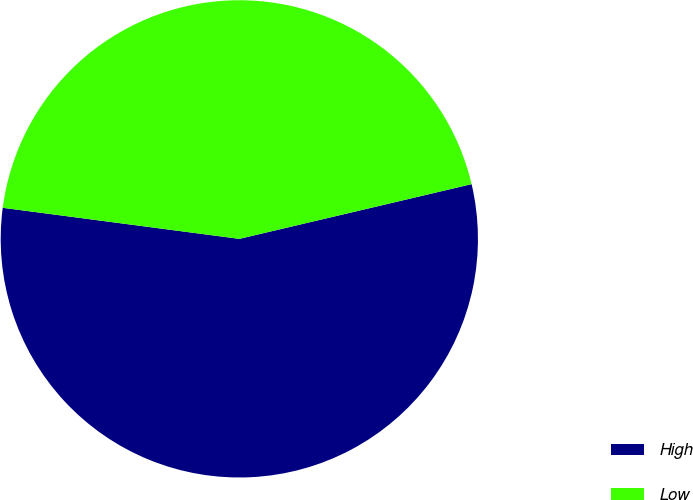<chart> <loc_0><loc_0><loc_500><loc_500><pie_chart><fcel>High<fcel>Low<nl><fcel>55.76%<fcel>44.24%<nl></chart> 